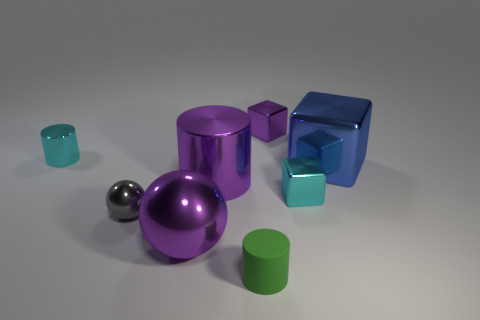Add 1 big matte cylinders. How many objects exist? 9 Subtract all cylinders. How many objects are left? 5 Subtract 0 green balls. How many objects are left? 8 Subtract all big blue things. Subtract all small cyan shiny blocks. How many objects are left? 6 Add 4 blue metal cubes. How many blue metal cubes are left? 5 Add 2 large blue metal spheres. How many large blue metal spheres exist? 2 